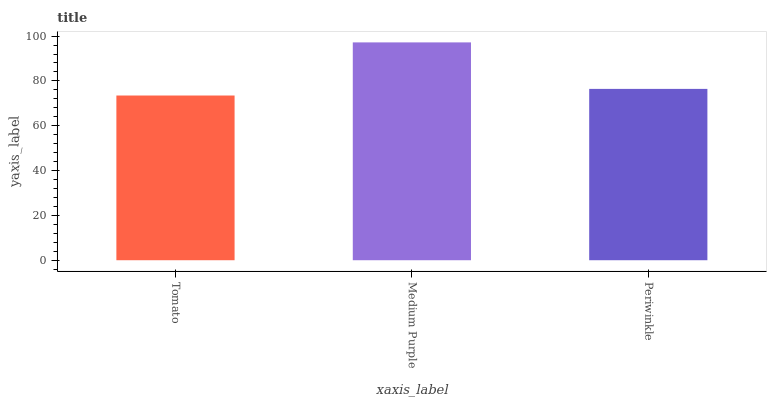Is Tomato the minimum?
Answer yes or no. Yes. Is Medium Purple the maximum?
Answer yes or no. Yes. Is Periwinkle the minimum?
Answer yes or no. No. Is Periwinkle the maximum?
Answer yes or no. No. Is Medium Purple greater than Periwinkle?
Answer yes or no. Yes. Is Periwinkle less than Medium Purple?
Answer yes or no. Yes. Is Periwinkle greater than Medium Purple?
Answer yes or no. No. Is Medium Purple less than Periwinkle?
Answer yes or no. No. Is Periwinkle the high median?
Answer yes or no. Yes. Is Periwinkle the low median?
Answer yes or no. Yes. Is Tomato the high median?
Answer yes or no. No. Is Tomato the low median?
Answer yes or no. No. 